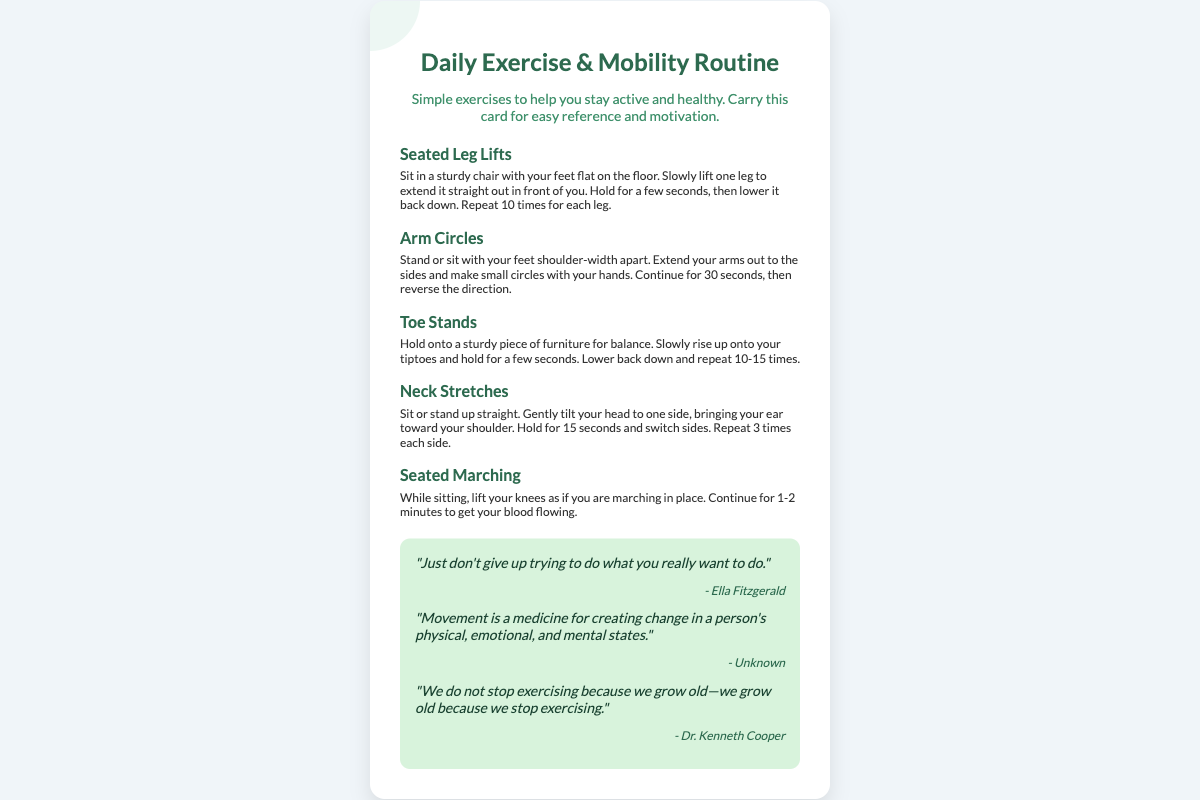What is the title of the document? The title is prominently displayed at the top of the document, indicating the content focus.
Answer: Daily Exercise & Mobility Routine How many exercises are listed? The document provides a list of different exercises under the exercises section, which can be counted.
Answer: 5 What is the first exercise mentioned? The first exercise is listed at the top of the exercises section.
Answer: Seated Leg Lifts What should you hold onto during Toe Stands? The document specifies the object for balance while performing the exercise.
Answer: A sturdy piece of furniture How long should you hold your head tilt during Neck Stretches? The document states the duration for holding each side during this exercise.
Answer: 15 seconds What is one of the quotes included in the document? The motivational quotes are part of the document and can be directly referenced.
Answer: "Just don't give up trying to do what you really want to do." Who is the author of the third quote? Each quote is accompanied by its respective author in the document.
Answer: Dr. Kenneth Cooper What is mentioned as a benefit of movement? The document outlines the benefits of movement as stated in one of its quotes.
Answer: Creating change in a person's physical, emotional, and mental states What color is the card's background? The card's background color is described within the style section of the document.
Answer: White 